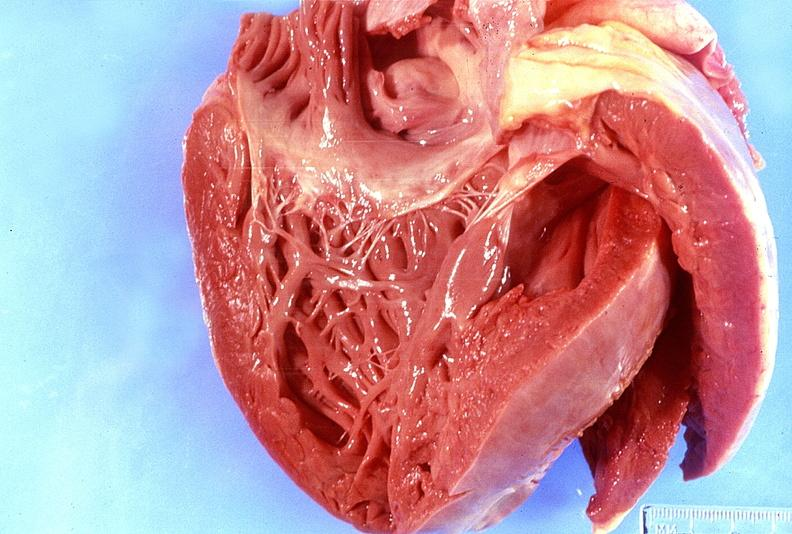s capillary present?
Answer the question using a single word or phrase. No 